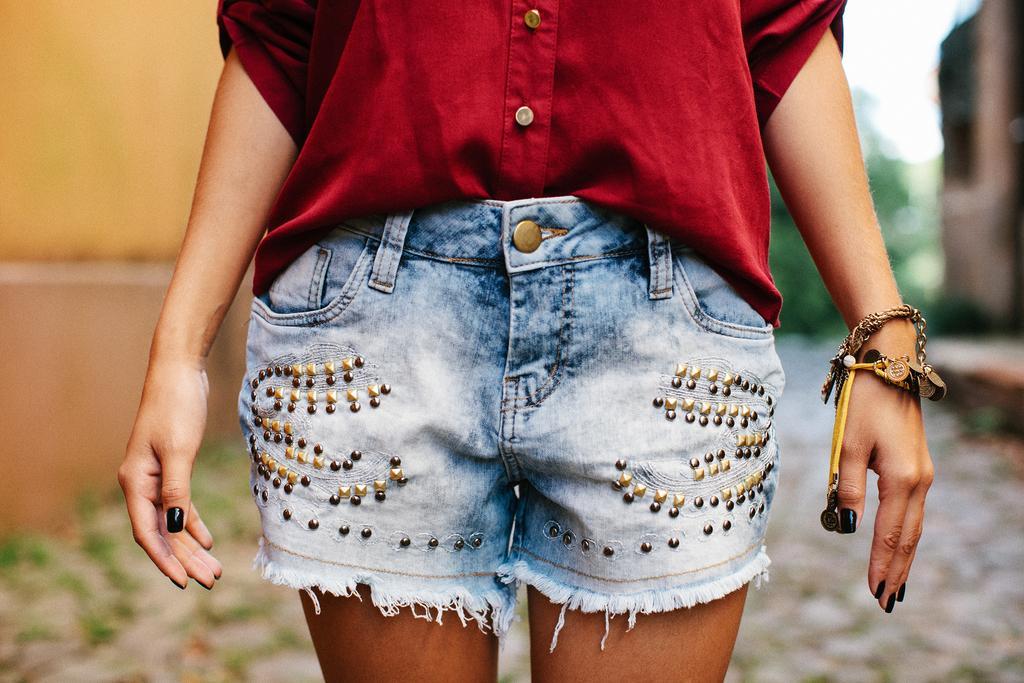Could you give a brief overview of what you see in this image? In the center of the image we can see a lady standing. She is wearing a red shirt. In the background there is a wall and trees. 